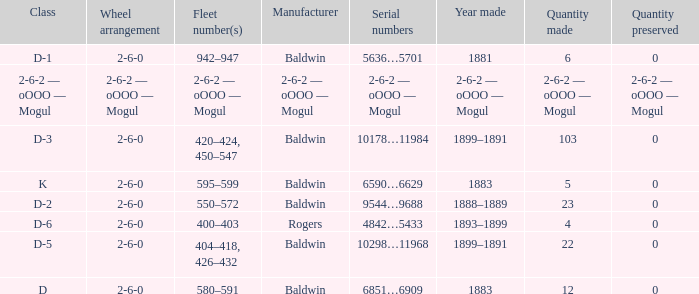What is the year made when the manufacturer is 2-6-2 — oooo — mogul? 2-6-2 — oOOO — Mogul. 